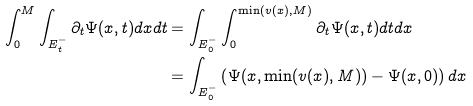<formula> <loc_0><loc_0><loc_500><loc_500>\int _ { 0 } ^ { M } \int _ { E _ { t } ^ { - } } \partial _ { t } { \Psi } ( x , t ) d x d t & = \int _ { E _ { 0 } ^ { - } } \int _ { 0 } ^ { \min ( v ( x ) , M ) } \partial _ { t } { \Psi } ( x , t ) d t d x \\ & = \int _ { E _ { 0 } ^ { - } } \left ( { \Psi } ( x , \min ( v ( x ) , M ) ) - { \Psi } ( x , 0 ) \right ) d x</formula> 